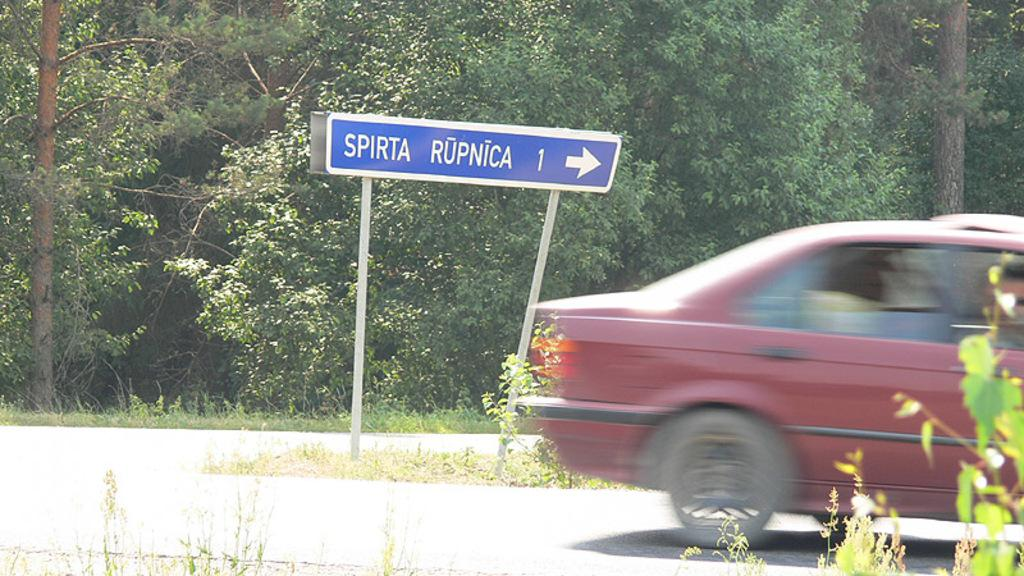What is the main object in the center of the image? There is a sign board in the center of the image. Where is the sign board located? The sign board is on the road. What else can be seen on the road in the image? There is a car on the right side of the image. Can you describe the car's position in the image? The car is on the road. What can be seen in the background of the image? There is a road, trees, and plants visible in the background of the image. What type of bread is being sold at the store in the image? There is no store or bread present in the image; it features a sign board, a car, and a road. Is the image taken during the winter season? The image does not provide any information about the season, so it cannot be determined if it was taken during winter. 